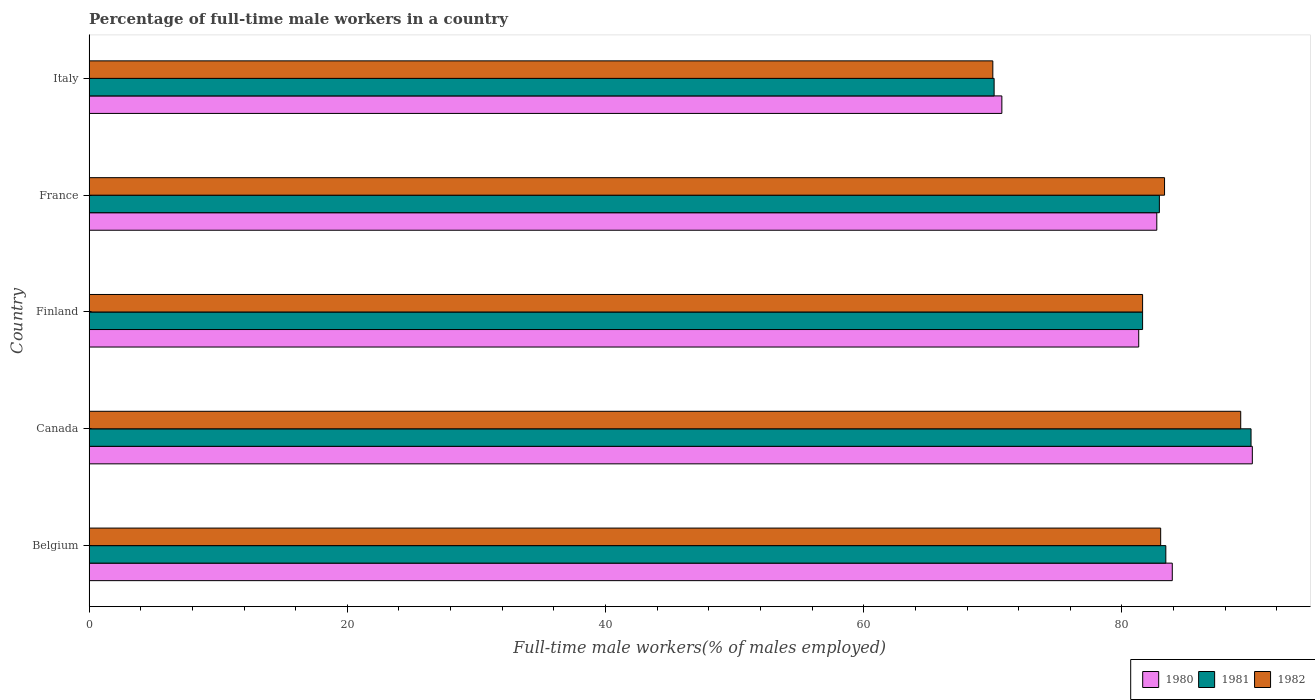How many different coloured bars are there?
Make the answer very short. 3. How many bars are there on the 4th tick from the bottom?
Your answer should be very brief. 3. What is the percentage of full-time male workers in 1980 in Finland?
Provide a short and direct response. 81.3. Across all countries, what is the maximum percentage of full-time male workers in 1981?
Provide a succinct answer. 90. Across all countries, what is the minimum percentage of full-time male workers in 1980?
Your answer should be compact. 70.7. In which country was the percentage of full-time male workers in 1982 maximum?
Make the answer very short. Canada. In which country was the percentage of full-time male workers in 1981 minimum?
Your answer should be very brief. Italy. What is the total percentage of full-time male workers in 1980 in the graph?
Provide a succinct answer. 408.7. What is the difference between the percentage of full-time male workers in 1982 in Finland and that in France?
Give a very brief answer. -1.7. What is the difference between the percentage of full-time male workers in 1981 in Canada and the percentage of full-time male workers in 1980 in Belgium?
Provide a succinct answer. 6.1. What is the average percentage of full-time male workers in 1980 per country?
Offer a very short reply. 81.74. What is the difference between the percentage of full-time male workers in 1982 and percentage of full-time male workers in 1980 in Canada?
Give a very brief answer. -0.9. What is the ratio of the percentage of full-time male workers in 1981 in Finland to that in France?
Keep it short and to the point. 0.98. What is the difference between the highest and the second highest percentage of full-time male workers in 1980?
Your response must be concise. 6.2. What is the difference between the highest and the lowest percentage of full-time male workers in 1982?
Offer a terse response. 19.2. In how many countries, is the percentage of full-time male workers in 1980 greater than the average percentage of full-time male workers in 1980 taken over all countries?
Your response must be concise. 3. Is the sum of the percentage of full-time male workers in 1980 in Belgium and Canada greater than the maximum percentage of full-time male workers in 1982 across all countries?
Keep it short and to the point. Yes. What does the 3rd bar from the top in France represents?
Provide a short and direct response. 1980. What does the 3rd bar from the bottom in Belgium represents?
Provide a short and direct response. 1982. Is it the case that in every country, the sum of the percentage of full-time male workers in 1980 and percentage of full-time male workers in 1982 is greater than the percentage of full-time male workers in 1981?
Your response must be concise. Yes. Are the values on the major ticks of X-axis written in scientific E-notation?
Offer a very short reply. No. Does the graph contain any zero values?
Ensure brevity in your answer.  No. Does the graph contain grids?
Make the answer very short. No. Where does the legend appear in the graph?
Ensure brevity in your answer.  Bottom right. What is the title of the graph?
Give a very brief answer. Percentage of full-time male workers in a country. What is the label or title of the X-axis?
Offer a terse response. Full-time male workers(% of males employed). What is the label or title of the Y-axis?
Provide a short and direct response. Country. What is the Full-time male workers(% of males employed) of 1980 in Belgium?
Offer a terse response. 83.9. What is the Full-time male workers(% of males employed) in 1981 in Belgium?
Ensure brevity in your answer.  83.4. What is the Full-time male workers(% of males employed) of 1980 in Canada?
Your answer should be very brief. 90.1. What is the Full-time male workers(% of males employed) in 1982 in Canada?
Your answer should be compact. 89.2. What is the Full-time male workers(% of males employed) in 1980 in Finland?
Offer a terse response. 81.3. What is the Full-time male workers(% of males employed) in 1981 in Finland?
Offer a very short reply. 81.6. What is the Full-time male workers(% of males employed) of 1982 in Finland?
Ensure brevity in your answer.  81.6. What is the Full-time male workers(% of males employed) in 1980 in France?
Your response must be concise. 82.7. What is the Full-time male workers(% of males employed) of 1981 in France?
Keep it short and to the point. 82.9. What is the Full-time male workers(% of males employed) of 1982 in France?
Give a very brief answer. 83.3. What is the Full-time male workers(% of males employed) of 1980 in Italy?
Offer a very short reply. 70.7. What is the Full-time male workers(% of males employed) in 1981 in Italy?
Your response must be concise. 70.1. What is the Full-time male workers(% of males employed) in 1982 in Italy?
Your answer should be very brief. 70. Across all countries, what is the maximum Full-time male workers(% of males employed) of 1980?
Your response must be concise. 90.1. Across all countries, what is the maximum Full-time male workers(% of males employed) in 1982?
Your response must be concise. 89.2. Across all countries, what is the minimum Full-time male workers(% of males employed) in 1980?
Keep it short and to the point. 70.7. Across all countries, what is the minimum Full-time male workers(% of males employed) in 1981?
Provide a succinct answer. 70.1. What is the total Full-time male workers(% of males employed) of 1980 in the graph?
Your answer should be compact. 408.7. What is the total Full-time male workers(% of males employed) in 1981 in the graph?
Provide a short and direct response. 408. What is the total Full-time male workers(% of males employed) of 1982 in the graph?
Offer a terse response. 407.1. What is the difference between the Full-time male workers(% of males employed) of 1980 in Belgium and that in Finland?
Your answer should be compact. 2.6. What is the difference between the Full-time male workers(% of males employed) in 1981 in Belgium and that in Finland?
Make the answer very short. 1.8. What is the difference between the Full-time male workers(% of males employed) in 1980 in Belgium and that in France?
Your response must be concise. 1.2. What is the difference between the Full-time male workers(% of males employed) in 1981 in Belgium and that in France?
Provide a short and direct response. 0.5. What is the difference between the Full-time male workers(% of males employed) of 1982 in Belgium and that in France?
Ensure brevity in your answer.  -0.3. What is the difference between the Full-time male workers(% of males employed) of 1980 in Belgium and that in Italy?
Your response must be concise. 13.2. What is the difference between the Full-time male workers(% of males employed) of 1980 in Canada and that in Finland?
Your response must be concise. 8.8. What is the difference between the Full-time male workers(% of males employed) in 1982 in Canada and that in Finland?
Your response must be concise. 7.6. What is the difference between the Full-time male workers(% of males employed) in 1982 in Canada and that in France?
Ensure brevity in your answer.  5.9. What is the difference between the Full-time male workers(% of males employed) in 1980 in Canada and that in Italy?
Keep it short and to the point. 19.4. What is the difference between the Full-time male workers(% of males employed) of 1981 in Canada and that in Italy?
Give a very brief answer. 19.9. What is the difference between the Full-time male workers(% of males employed) in 1982 in Canada and that in Italy?
Your response must be concise. 19.2. What is the difference between the Full-time male workers(% of males employed) in 1982 in Finland and that in France?
Keep it short and to the point. -1.7. What is the difference between the Full-time male workers(% of males employed) of 1980 in Finland and that in Italy?
Give a very brief answer. 10.6. What is the difference between the Full-time male workers(% of males employed) in 1980 in France and that in Italy?
Your answer should be compact. 12. What is the difference between the Full-time male workers(% of males employed) of 1982 in France and that in Italy?
Give a very brief answer. 13.3. What is the difference between the Full-time male workers(% of males employed) of 1980 in Belgium and the Full-time male workers(% of males employed) of 1982 in Canada?
Give a very brief answer. -5.3. What is the difference between the Full-time male workers(% of males employed) in 1981 in Belgium and the Full-time male workers(% of males employed) in 1982 in Finland?
Your answer should be very brief. 1.8. What is the difference between the Full-time male workers(% of males employed) in 1980 in Belgium and the Full-time male workers(% of males employed) in 1982 in France?
Provide a succinct answer. 0.6. What is the difference between the Full-time male workers(% of males employed) in 1981 in Belgium and the Full-time male workers(% of males employed) in 1982 in France?
Offer a terse response. 0.1. What is the difference between the Full-time male workers(% of males employed) in 1980 in Belgium and the Full-time male workers(% of males employed) in 1981 in Italy?
Keep it short and to the point. 13.8. What is the difference between the Full-time male workers(% of males employed) of 1981 in Belgium and the Full-time male workers(% of males employed) of 1982 in Italy?
Your answer should be very brief. 13.4. What is the difference between the Full-time male workers(% of males employed) in 1980 in Canada and the Full-time male workers(% of males employed) in 1982 in Finland?
Offer a terse response. 8.5. What is the difference between the Full-time male workers(% of males employed) in 1980 in Canada and the Full-time male workers(% of males employed) in 1981 in France?
Give a very brief answer. 7.2. What is the difference between the Full-time male workers(% of males employed) in 1980 in Canada and the Full-time male workers(% of males employed) in 1982 in Italy?
Keep it short and to the point. 20.1. What is the difference between the Full-time male workers(% of males employed) of 1980 in Finland and the Full-time male workers(% of males employed) of 1981 in France?
Your answer should be compact. -1.6. What is the difference between the Full-time male workers(% of males employed) in 1980 in Finland and the Full-time male workers(% of males employed) in 1982 in France?
Your answer should be compact. -2. What is the difference between the Full-time male workers(% of males employed) in 1980 in Finland and the Full-time male workers(% of males employed) in 1982 in Italy?
Your answer should be very brief. 11.3. What is the difference between the Full-time male workers(% of males employed) of 1981 in Finland and the Full-time male workers(% of males employed) of 1982 in Italy?
Offer a terse response. 11.6. What is the difference between the Full-time male workers(% of males employed) in 1980 in France and the Full-time male workers(% of males employed) in 1982 in Italy?
Offer a terse response. 12.7. What is the average Full-time male workers(% of males employed) in 1980 per country?
Your answer should be very brief. 81.74. What is the average Full-time male workers(% of males employed) of 1981 per country?
Provide a short and direct response. 81.6. What is the average Full-time male workers(% of males employed) of 1982 per country?
Offer a very short reply. 81.42. What is the difference between the Full-time male workers(% of males employed) in 1980 and Full-time male workers(% of males employed) in 1982 in Belgium?
Your answer should be compact. 0.9. What is the difference between the Full-time male workers(% of males employed) in 1981 and Full-time male workers(% of males employed) in 1982 in Belgium?
Your answer should be very brief. 0.4. What is the difference between the Full-time male workers(% of males employed) in 1980 and Full-time male workers(% of males employed) in 1982 in Canada?
Your answer should be very brief. 0.9. What is the difference between the Full-time male workers(% of males employed) in 1980 and Full-time male workers(% of males employed) in 1981 in Finland?
Your answer should be very brief. -0.3. What is the difference between the Full-time male workers(% of males employed) of 1980 and Full-time male workers(% of males employed) of 1982 in Finland?
Keep it short and to the point. -0.3. What is the difference between the Full-time male workers(% of males employed) in 1981 and Full-time male workers(% of males employed) in 1982 in France?
Make the answer very short. -0.4. What is the difference between the Full-time male workers(% of males employed) of 1980 and Full-time male workers(% of males employed) of 1981 in Italy?
Offer a terse response. 0.6. What is the difference between the Full-time male workers(% of males employed) in 1980 and Full-time male workers(% of males employed) in 1982 in Italy?
Provide a short and direct response. 0.7. What is the difference between the Full-time male workers(% of males employed) of 1981 and Full-time male workers(% of males employed) of 1982 in Italy?
Ensure brevity in your answer.  0.1. What is the ratio of the Full-time male workers(% of males employed) of 1980 in Belgium to that in Canada?
Offer a terse response. 0.93. What is the ratio of the Full-time male workers(% of males employed) of 1981 in Belgium to that in Canada?
Make the answer very short. 0.93. What is the ratio of the Full-time male workers(% of males employed) of 1982 in Belgium to that in Canada?
Provide a succinct answer. 0.93. What is the ratio of the Full-time male workers(% of males employed) of 1980 in Belgium to that in Finland?
Offer a terse response. 1.03. What is the ratio of the Full-time male workers(% of males employed) in 1981 in Belgium to that in Finland?
Offer a very short reply. 1.02. What is the ratio of the Full-time male workers(% of males employed) of 1982 in Belgium to that in Finland?
Give a very brief answer. 1.02. What is the ratio of the Full-time male workers(% of males employed) in 1980 in Belgium to that in France?
Keep it short and to the point. 1.01. What is the ratio of the Full-time male workers(% of males employed) of 1980 in Belgium to that in Italy?
Your response must be concise. 1.19. What is the ratio of the Full-time male workers(% of males employed) of 1981 in Belgium to that in Italy?
Give a very brief answer. 1.19. What is the ratio of the Full-time male workers(% of males employed) of 1982 in Belgium to that in Italy?
Provide a succinct answer. 1.19. What is the ratio of the Full-time male workers(% of males employed) of 1980 in Canada to that in Finland?
Provide a short and direct response. 1.11. What is the ratio of the Full-time male workers(% of males employed) in 1981 in Canada to that in Finland?
Ensure brevity in your answer.  1.1. What is the ratio of the Full-time male workers(% of males employed) of 1982 in Canada to that in Finland?
Your answer should be compact. 1.09. What is the ratio of the Full-time male workers(% of males employed) in 1980 in Canada to that in France?
Offer a terse response. 1.09. What is the ratio of the Full-time male workers(% of males employed) of 1981 in Canada to that in France?
Provide a succinct answer. 1.09. What is the ratio of the Full-time male workers(% of males employed) of 1982 in Canada to that in France?
Ensure brevity in your answer.  1.07. What is the ratio of the Full-time male workers(% of males employed) of 1980 in Canada to that in Italy?
Keep it short and to the point. 1.27. What is the ratio of the Full-time male workers(% of males employed) in 1981 in Canada to that in Italy?
Make the answer very short. 1.28. What is the ratio of the Full-time male workers(% of males employed) in 1982 in Canada to that in Italy?
Ensure brevity in your answer.  1.27. What is the ratio of the Full-time male workers(% of males employed) in 1980 in Finland to that in France?
Make the answer very short. 0.98. What is the ratio of the Full-time male workers(% of males employed) in 1981 in Finland to that in France?
Your response must be concise. 0.98. What is the ratio of the Full-time male workers(% of males employed) in 1982 in Finland to that in France?
Keep it short and to the point. 0.98. What is the ratio of the Full-time male workers(% of males employed) in 1980 in Finland to that in Italy?
Make the answer very short. 1.15. What is the ratio of the Full-time male workers(% of males employed) of 1981 in Finland to that in Italy?
Your response must be concise. 1.16. What is the ratio of the Full-time male workers(% of males employed) of 1982 in Finland to that in Italy?
Provide a succinct answer. 1.17. What is the ratio of the Full-time male workers(% of males employed) of 1980 in France to that in Italy?
Your response must be concise. 1.17. What is the ratio of the Full-time male workers(% of males employed) in 1981 in France to that in Italy?
Offer a terse response. 1.18. What is the ratio of the Full-time male workers(% of males employed) in 1982 in France to that in Italy?
Make the answer very short. 1.19. What is the difference between the highest and the second highest Full-time male workers(% of males employed) in 1980?
Provide a succinct answer. 6.2. What is the difference between the highest and the lowest Full-time male workers(% of males employed) of 1981?
Offer a very short reply. 19.9. What is the difference between the highest and the lowest Full-time male workers(% of males employed) in 1982?
Provide a succinct answer. 19.2. 